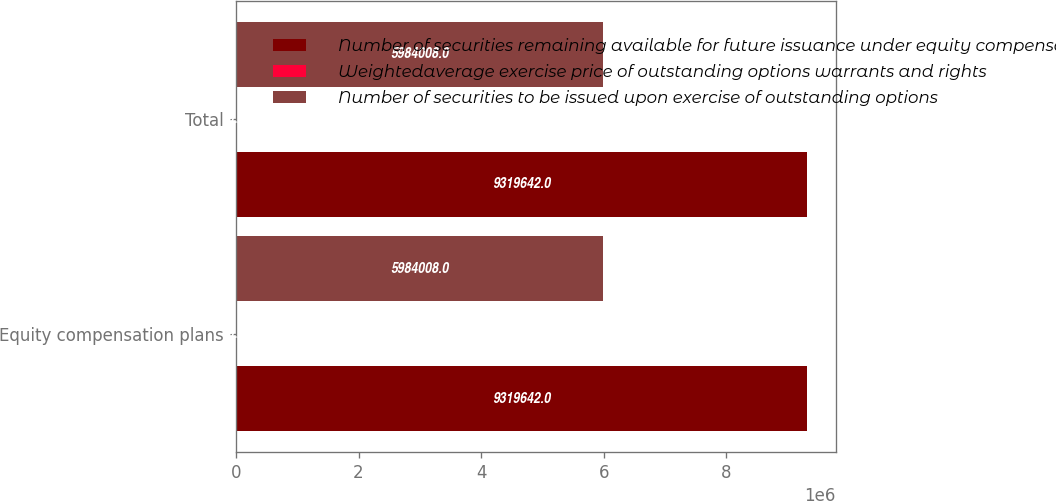Convert chart to OTSL. <chart><loc_0><loc_0><loc_500><loc_500><stacked_bar_chart><ecel><fcel>Equity compensation plans<fcel>Total<nl><fcel>Number of securities remaining available for future issuance under equity compensation plans excluding securities reflected in column a<fcel>9.31964e+06<fcel>9.31964e+06<nl><fcel>Weightedaverage exercise price of outstanding options warrants and rights<fcel>19.21<fcel>19.21<nl><fcel>Number of securities to be issued upon exercise of outstanding options<fcel>5.98401e+06<fcel>5.98401e+06<nl></chart> 